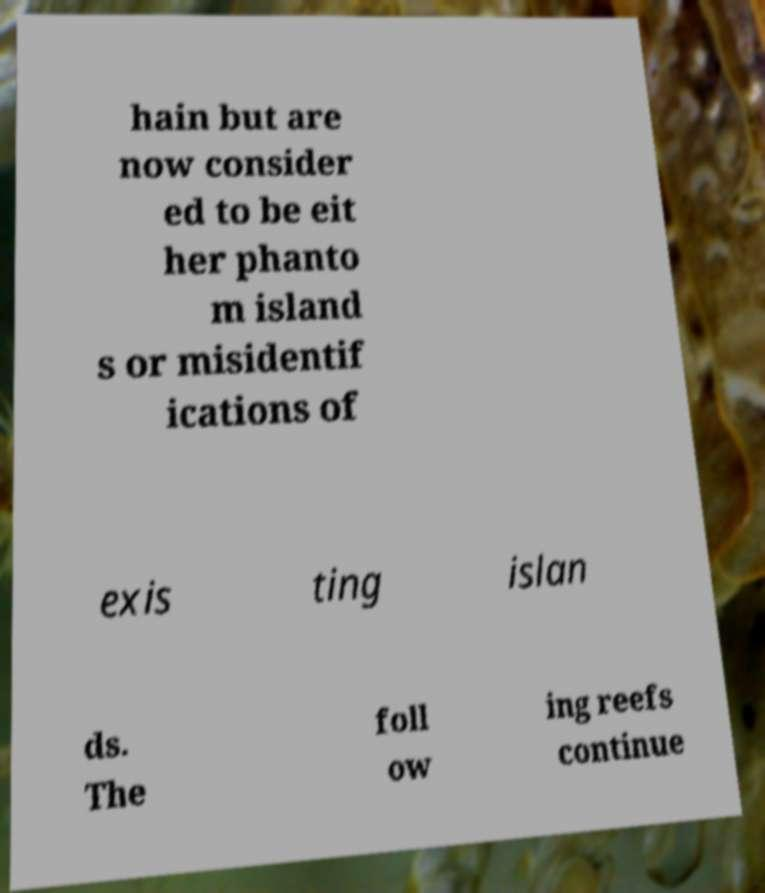I need the written content from this picture converted into text. Can you do that? hain but are now consider ed to be eit her phanto m island s or misidentif ications of exis ting islan ds. The foll ow ing reefs continue 